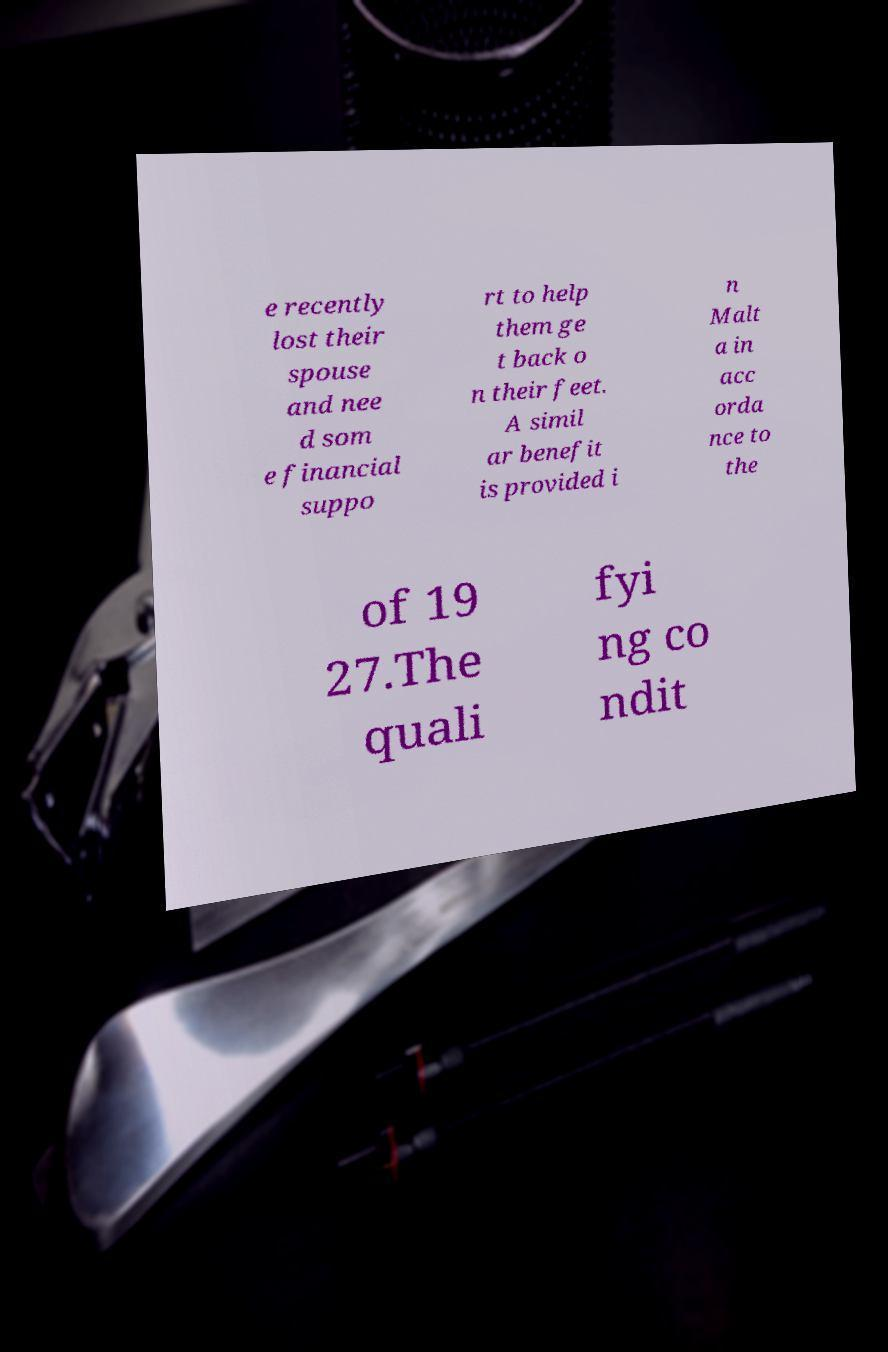Could you assist in decoding the text presented in this image and type it out clearly? e recently lost their spouse and nee d som e financial suppo rt to help them ge t back o n their feet. A simil ar benefit is provided i n Malt a in acc orda nce to the of 19 27.The quali fyi ng co ndit 